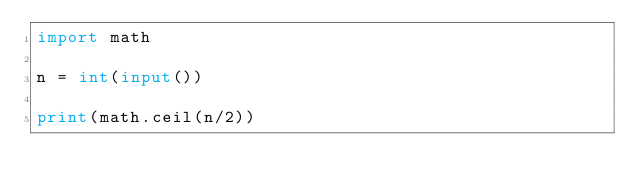<code> <loc_0><loc_0><loc_500><loc_500><_Python_>import math

n = int(input())

print(math.ceil(n/2))</code> 